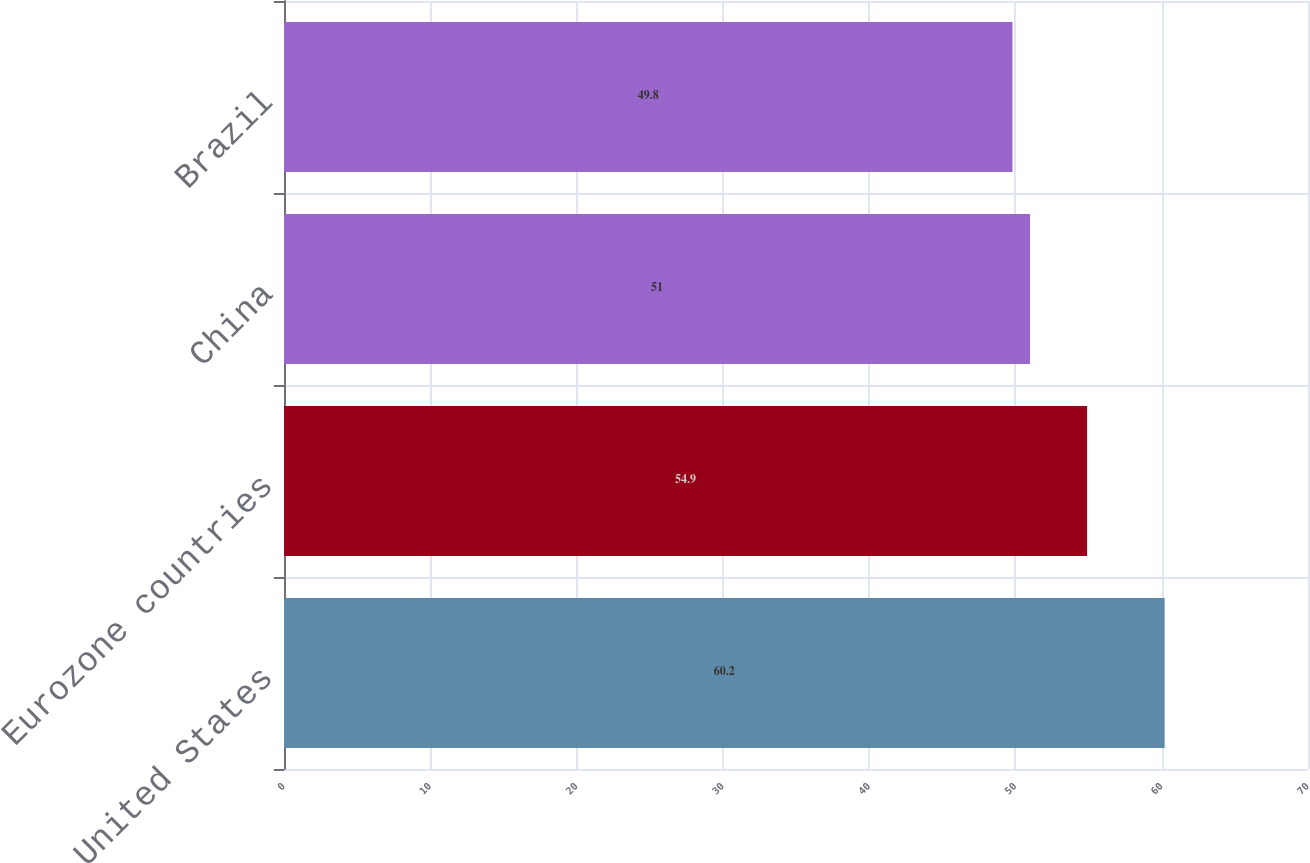Convert chart. <chart><loc_0><loc_0><loc_500><loc_500><bar_chart><fcel>United States<fcel>Eurozone countries<fcel>China<fcel>Brazil<nl><fcel>60.2<fcel>54.9<fcel>51<fcel>49.8<nl></chart> 